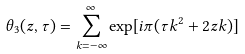<formula> <loc_0><loc_0><loc_500><loc_500>\theta _ { 3 } ( z , \tau ) = \sum _ { k = - \infty } ^ { \infty } \exp [ i \pi ( \tau k ^ { 2 } + 2 z k ) ]</formula> 